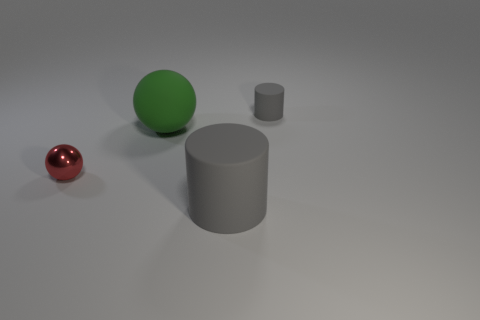Add 2 small gray rubber cylinders. How many objects exist? 6 Add 2 gray objects. How many gray objects are left? 4 Add 1 tiny red shiny balls. How many tiny red shiny balls exist? 2 Subtract 0 purple cubes. How many objects are left? 4 Subtract all large green rubber balls. Subtract all big rubber spheres. How many objects are left? 2 